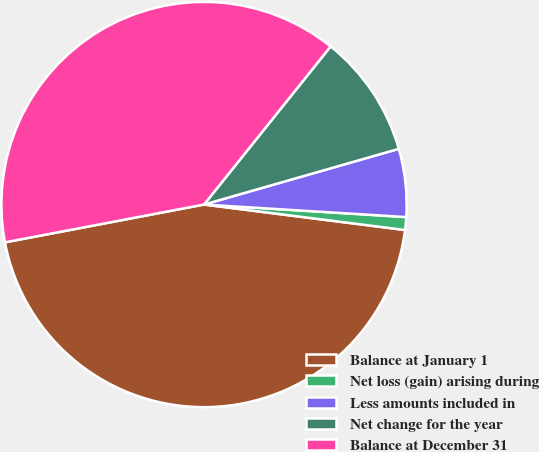Convert chart. <chart><loc_0><loc_0><loc_500><loc_500><pie_chart><fcel>Balance at January 1<fcel>Net loss (gain) arising during<fcel>Less amounts included in<fcel>Net change for the year<fcel>Balance at December 31<nl><fcel>45.01%<fcel>1.02%<fcel>5.42%<fcel>9.82%<fcel>38.74%<nl></chart> 